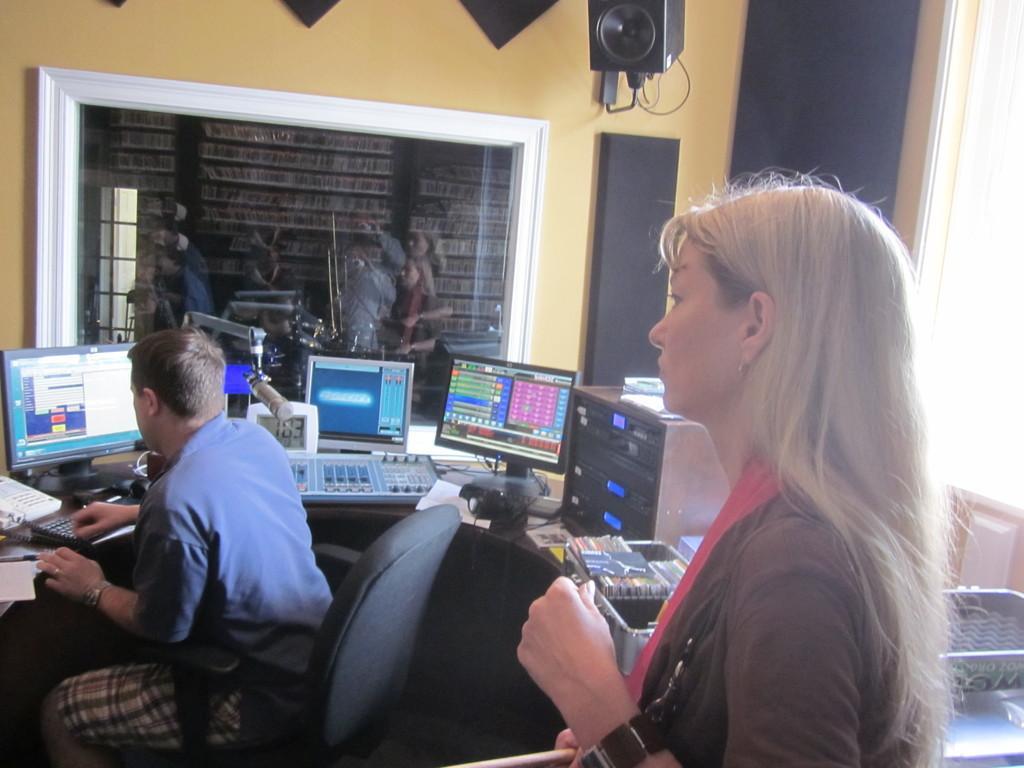Can you describe this image briefly? There is a room which includes two persons, a Man is sitting on the chair at the left side working on computer and a woman is standing at the right side looking at computer screen. There are three computers placed on the table and there is a window from which we can see the cabinet and there is a wall mounted speaker. 